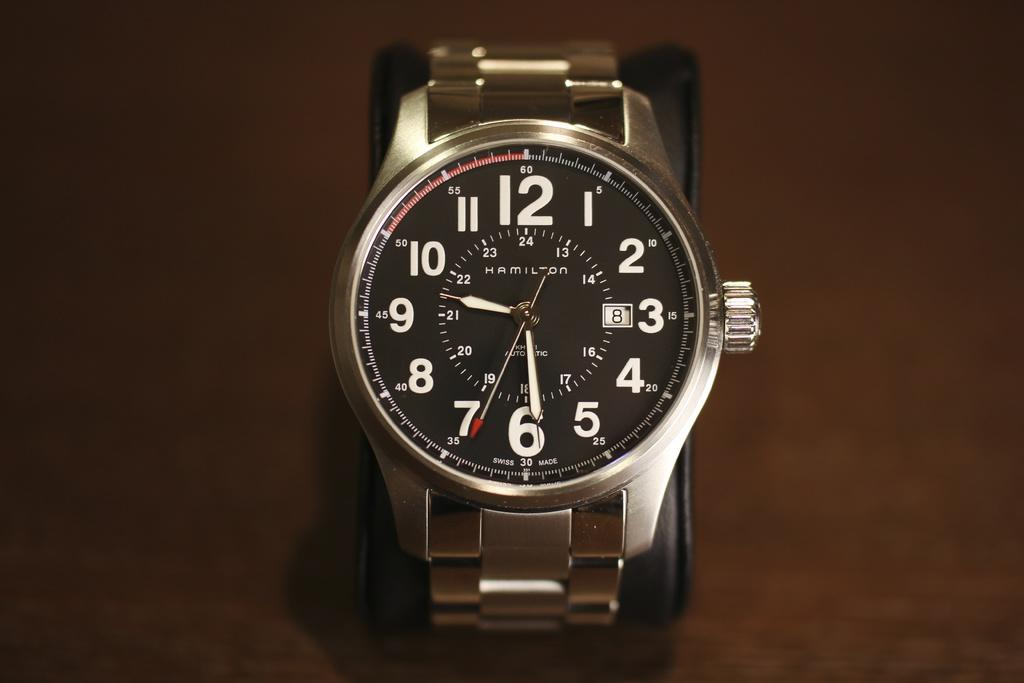<image>
Provide a brief description of the given image. A Hamilton watch sitting on a brown surface shows that today is the 8th. 